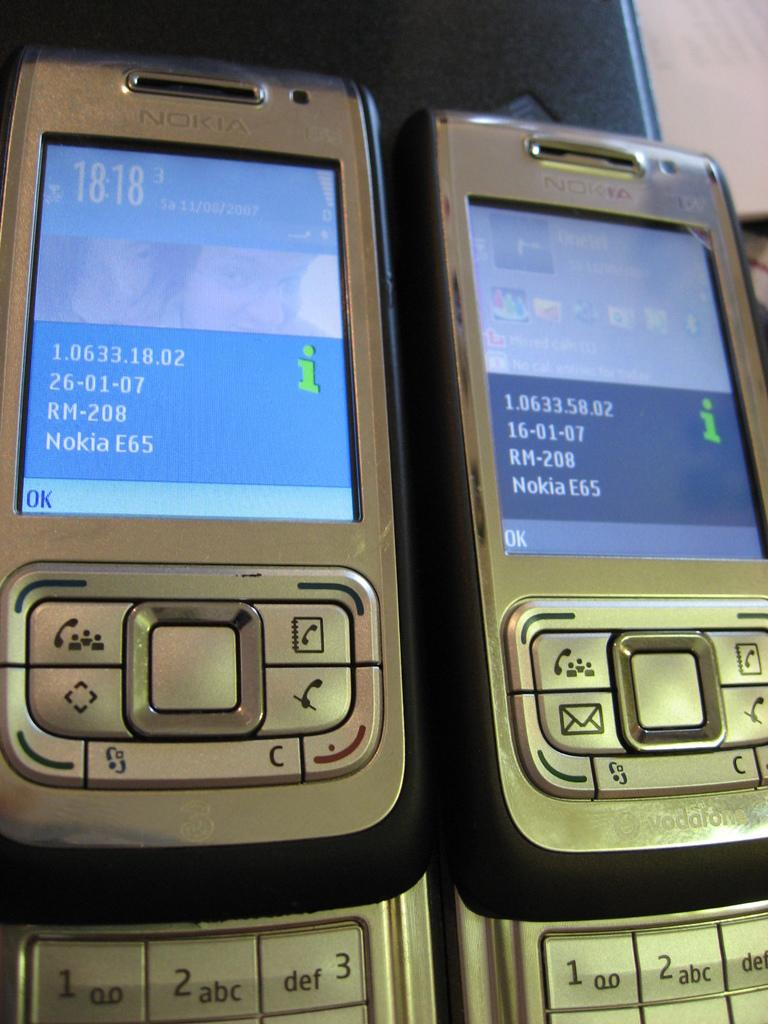Provide a one-sentence caption for the provided image. Two Nokia slide phones are side by side with the phone information on the screens. 